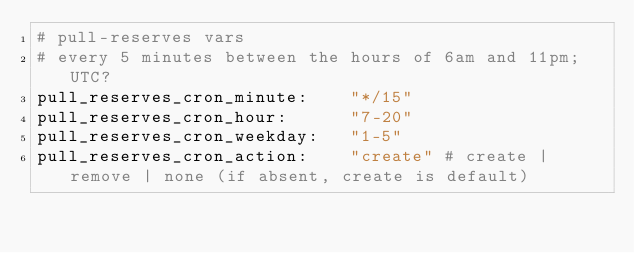<code> <loc_0><loc_0><loc_500><loc_500><_YAML_># pull-reserves vars
# every 5 minutes between the hours of 6am and 11pm; UTC?
pull_reserves_cron_minute:    "*/15"
pull_reserves_cron_hour:      "7-20"
pull_reserves_cron_weekday:   "1-5"
pull_reserves_cron_action:    "create" # create | remove | none (if absent, create is default)
</code> 